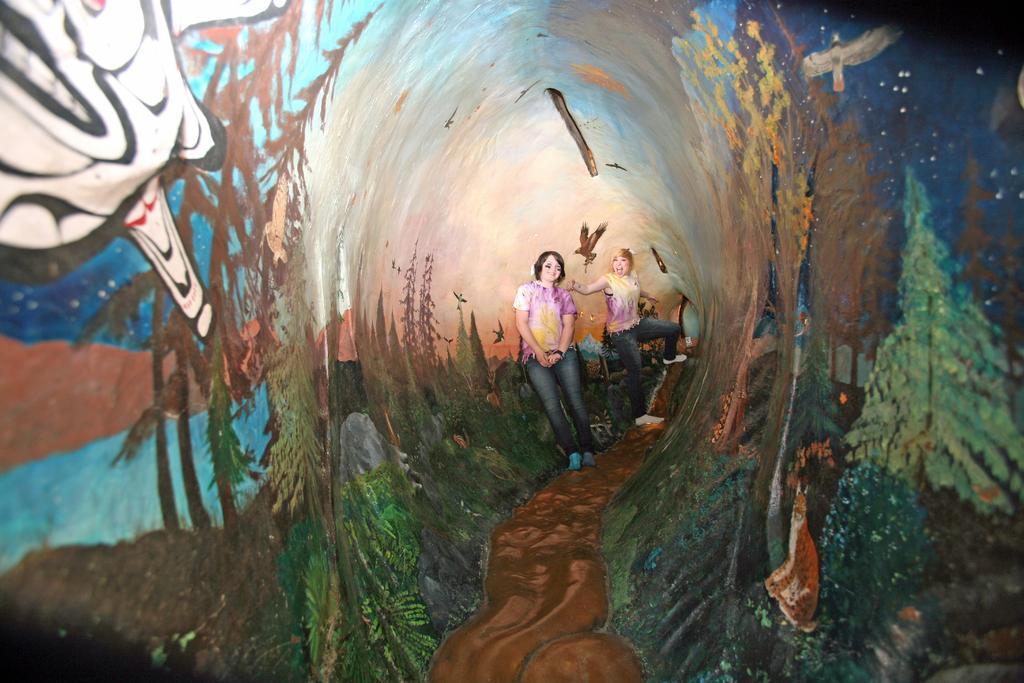How would you summarize this image in a sentence or two? Here in this picture we can see a painting present on a board and in the middle of it we can see a painting of two women standing over a place and around them we can see plants and trees present. 